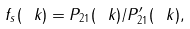Convert formula to latex. <formula><loc_0><loc_0><loc_500><loc_500>f _ { s } ( \ k ) = P _ { 2 1 } ( \ k ) / P ^ { \prime } _ { 2 1 } ( \ k ) ,</formula> 